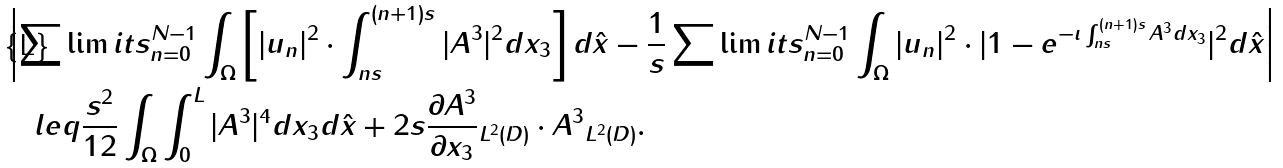Convert formula to latex. <formula><loc_0><loc_0><loc_500><loc_500>& \left | \sum \lim i t s _ { n = 0 } ^ { N - 1 } \int _ { \Omega } \left [ | u _ { n } | ^ { 2 } \cdot \int _ { n s } ^ { ( n + 1 ) s } | A ^ { 3 } | ^ { 2 } d x _ { 3 } \right ] d \hat { x } - \frac { 1 } { s } \sum \lim i t s _ { n = 0 } ^ { N - 1 } \int _ { \Omega } | u _ { n } | ^ { 2 } \cdot | 1 - e ^ { - \imath \int _ { n s } ^ { ( n + 1 ) s } A ^ { 3 } d x _ { 3 } } | ^ { 2 } d \hat { x } \right | \\ & \quad l e q \frac { s ^ { 2 } } { 1 2 } \int _ { \Omega } \int _ { 0 } ^ { L } | A ^ { 3 } | ^ { 4 } d x _ { 3 } d \hat { x } + 2 s \| \frac { \partial A ^ { 3 } } { \partial x _ { 3 } } \| _ { L ^ { 2 } ( D ) } \cdot \| A ^ { 3 } \| _ { L ^ { 2 } ( D ) } .</formula> 